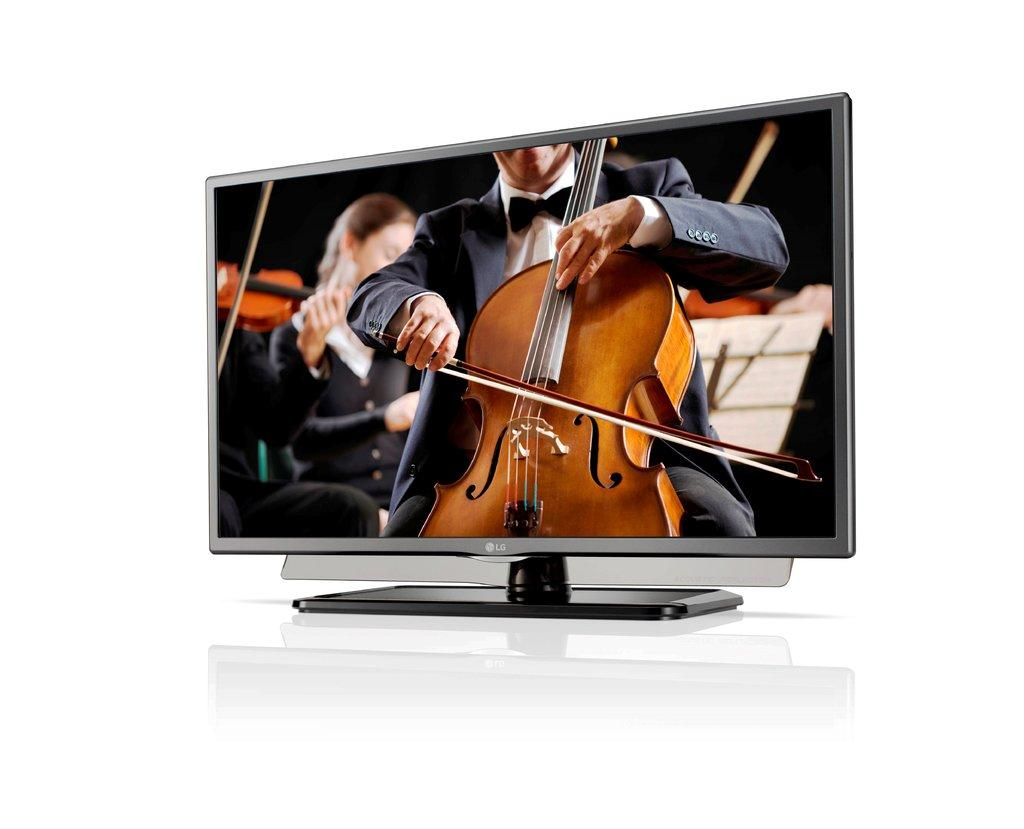How many people are in the image? There are persons in the image. What are the persons holding in their hands? The persons are holding violins in their hands. What type of record can be seen on the floor in the image? There is no record present in the image; the persons are holding violins. What liquid is being used to play the violins in the image? Violins do not require liquid to play, so there is no liquid involved in the image. 